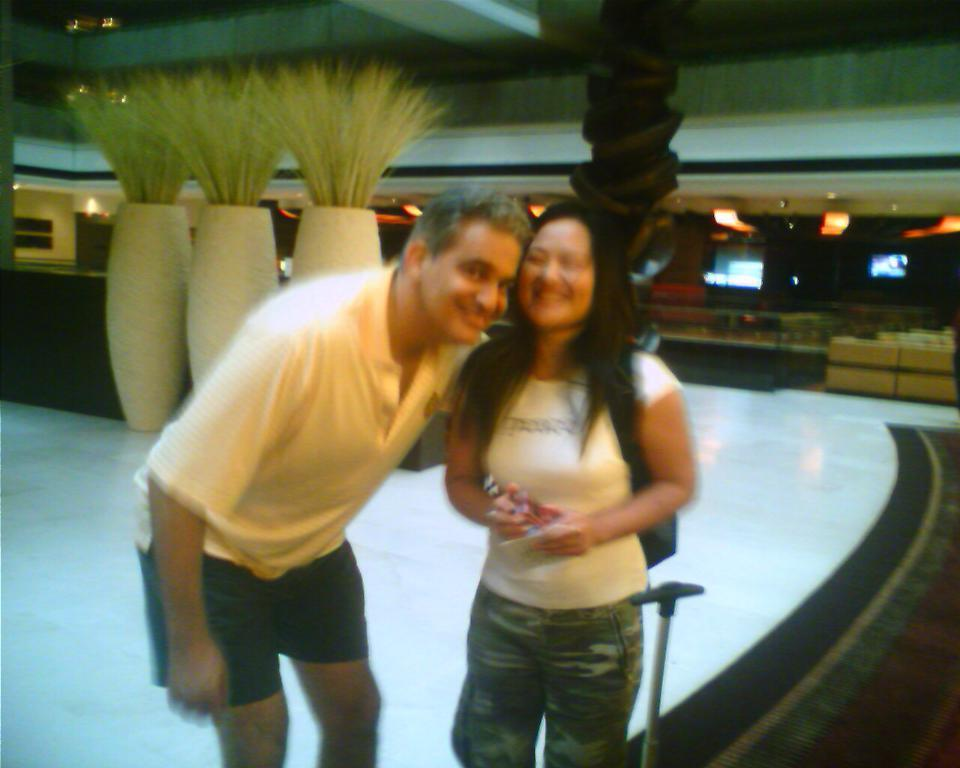Who is present in the image? There is a man and a woman in the image. What are the facial expressions of the people in the image? Both the man and the woman are smiling in the image. What can be seen in the background of the image? There are sofa chairs in the background of the image. What type of quince is the man attempting to bite in the image? There is no quince present in the image, and the man is not attempting to bite anything. 